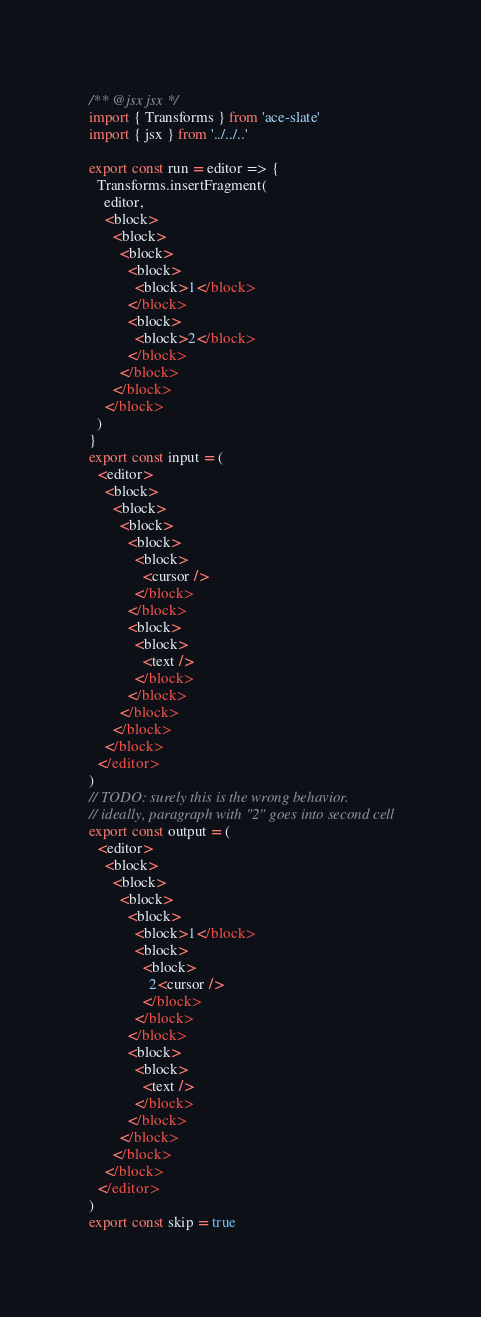Convert code to text. <code><loc_0><loc_0><loc_500><loc_500><_TypeScript_>/** @jsx jsx */
import { Transforms } from 'ace-slate'
import { jsx } from '../../..'

export const run = editor => {
  Transforms.insertFragment(
    editor,
    <block>
      <block>
        <block>
          <block>
            <block>1</block>
          </block>
          <block>
            <block>2</block>
          </block>
        </block>
      </block>
    </block>
  )
}
export const input = (
  <editor>
    <block>
      <block>
        <block>
          <block>
            <block>
              <cursor />
            </block>
          </block>
          <block>
            <block>
              <text />
            </block>
          </block>
        </block>
      </block>
    </block>
  </editor>
)
// TODO: surely this is the wrong behavior.
// ideally, paragraph with "2" goes into second cell
export const output = (
  <editor>
    <block>
      <block>
        <block>
          <block>
            <block>1</block>
            <block>
              <block>
                2<cursor />
              </block>
            </block>
          </block>
          <block>
            <block>
              <text />
            </block>
          </block>
        </block>
      </block>
    </block>
  </editor>
)
export const skip = true
</code> 